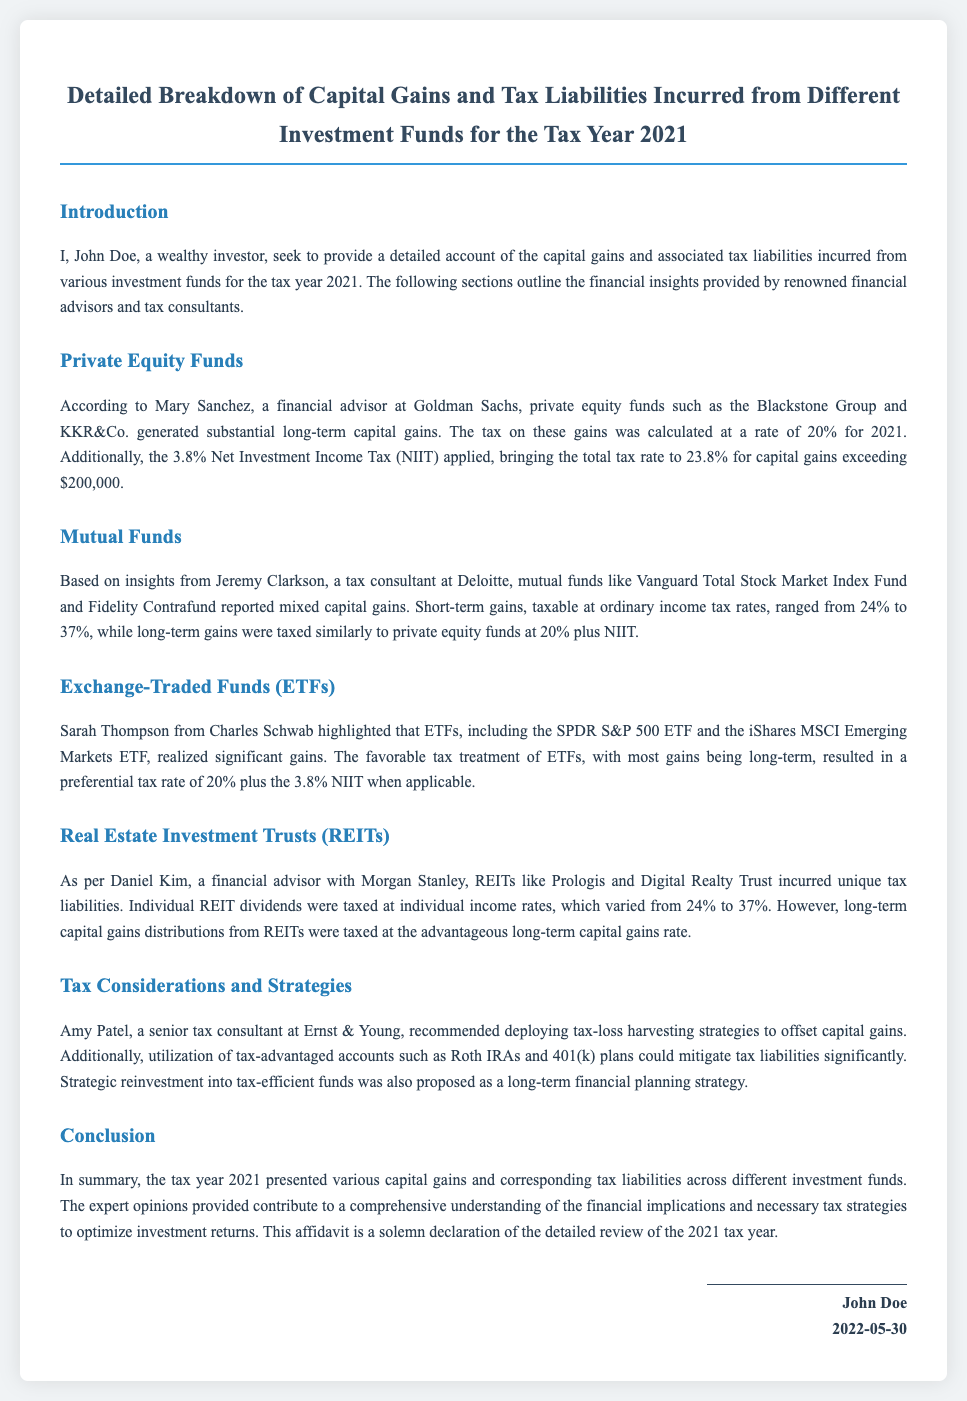What is the total tax rate on private equity gains? The total tax rate on private equity gains is calculated at 20% plus 3.8% NIIT.
Answer: 23.8% Which financial advisor provided insights on private equity funds? Mary Sanchez, a financial advisor at Goldman Sachs, provided insights on private equity funds.
Answer: Mary Sanchez What was the highest ordinary income tax rate mentioned for short-term gains on mutual funds? The ordinary income tax rates for short-term gains on mutual funds ranged from 24% to 37%.
Answer: 37% What investment funds did Sarah Thompson discuss? Sarah Thompson discussed the SPDR S&P 500 ETF and the iShares MSCI Emerging Markets ETF.
Answer: SPDR S&P 500 ETF and iShares MSCI Emerging Markets ETF What tax strategy did Amy Patel recommend? Amy Patel recommended deploying tax-loss harvesting strategies to offset capital gains.
Answer: Tax-loss harvesting Which investment funds had mixed capital gains? Mutual funds like Vanguard Total Stock Market Index Fund and Fidelity Contrafund had mixed capital gains.
Answer: Mutual funds What is the effective tax on long-term capital gains from ETFs? The effective tax on long-term capital gains from ETFs includes the rate of 20% plus 3.8% NIIT when applicable.
Answer: 20% plus 3.8% NIIT On what date was this affidavit signed? The affidavit was signed on May 30, 2022.
Answer: 2022-05-30 Who provided insights on REITs' tax liabilities? Daniel Kim, a financial advisor with Morgan Stanley, provided insights on REITs' tax liabilities.
Answer: Daniel Kim 